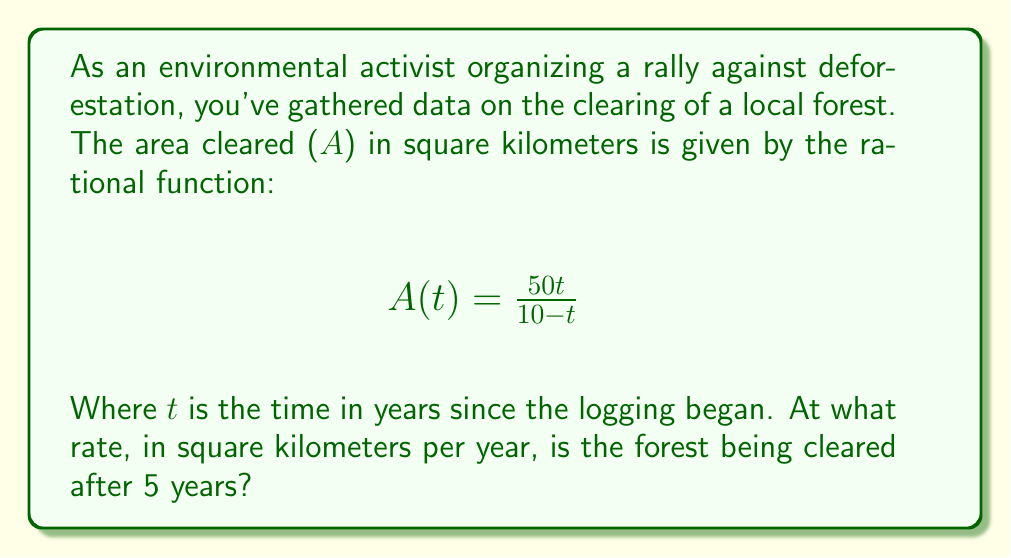Give your solution to this math problem. To find the rate of deforestation after 5 years, we need to calculate the derivative of A(t) and evaluate it at t = 5. This will give us the instantaneous rate of change.

Step 1: Find the derivative of A(t) using the quotient rule.
Let $u = 50t$ and $v = 10-t$
$$A'(t) = \frac{u'v - v'u}{v^2} = \frac{50(10-t) - (-1)(50t)}{(10-t)^2}$$

Step 2: Simplify the numerator
$$A'(t) = \frac{500 - 50t + 50t}{(10-t)^2} = \frac{500}{(10-t)^2}$$

Step 3: Evaluate A'(t) at t = 5
$$A'(5) = \frac{500}{(10-5)^2} = \frac{500}{25} = 20$$

Therefore, after 5 years, the forest is being cleared at a rate of 20 square kilometers per year.
Answer: 20 km²/year 